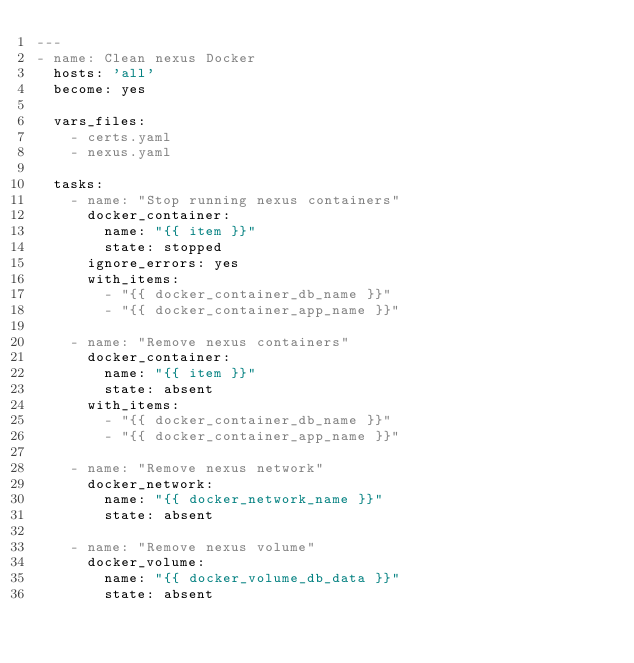Convert code to text. <code><loc_0><loc_0><loc_500><loc_500><_YAML_>---
- name: Clean nexus Docker
  hosts: 'all'
  become: yes

  vars_files:
    - certs.yaml
    - nexus.yaml

  tasks:
    - name: "Stop running nexus containers"
      docker_container:
        name: "{{ item }}"
        state: stopped
      ignore_errors: yes
      with_items:
        - "{{ docker_container_db_name }}"
        - "{{ docker_container_app_name }}"

    - name: "Remove nexus containers"
      docker_container:
        name: "{{ item }}"
        state: absent
      with_items:
        - "{{ docker_container_db_name }}"
        - "{{ docker_container_app_name }}"

    - name: "Remove nexus network"
      docker_network:
        name: "{{ docker_network_name }}"
        state: absent

    - name: "Remove nexus volume"
      docker_volume:
        name: "{{ docker_volume_db_data }}"
        state: absent

</code> 